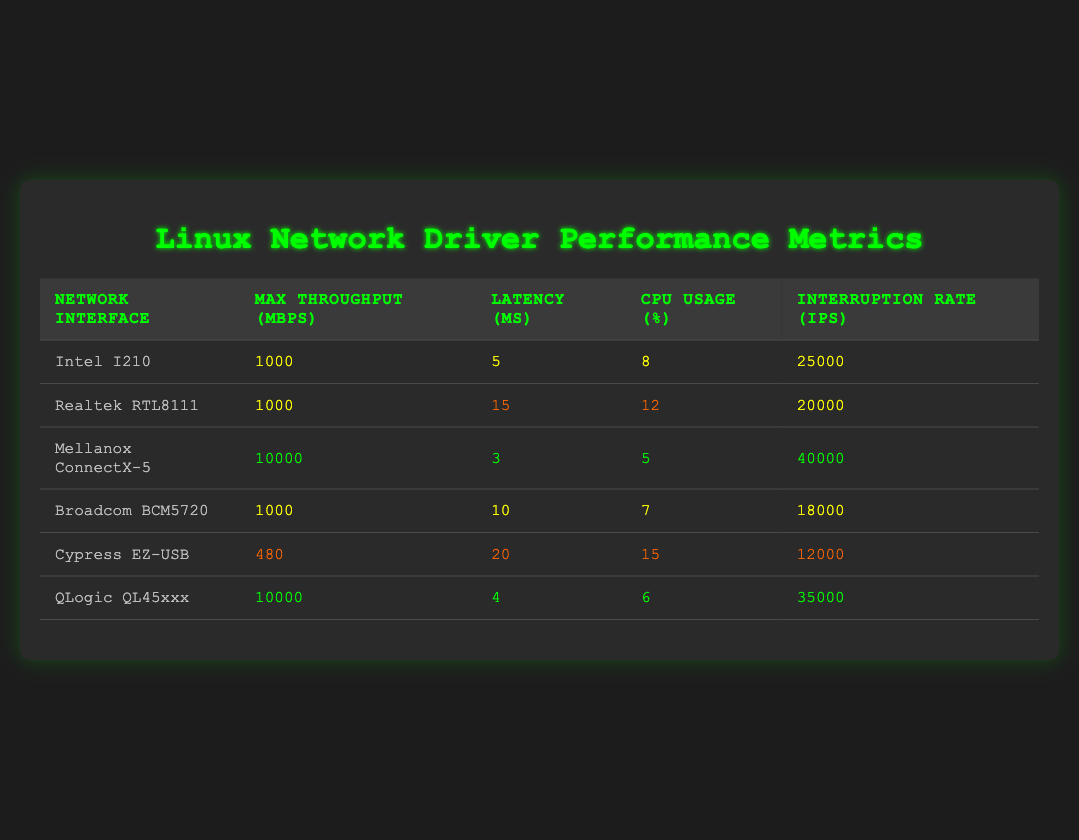What is the max throughput of the Realtek RTL8111? The max throughput for the Realtek RTL8111, as shown in the table, is specifically listed under the "Max Throughput (Mbps)" column, where it states 1000 Mbps.
Answer: 1000 Mbps Which network interface has the lowest CPU usage? By comparing the CPU usage percentage across all the entries in the table, the Cypress EZ-USB has the lowest CPU usage at 15%.
Answer: Cypress EZ-USB What is the average latency of network interfaces with a max throughput of 1000 Mbps? The relevant entries with a max throughput of 1000 Mbps are Intel I210, Realtek RTL8111, Broadcom BCM5720. Their latencies are 5, 15, and 10 microseconds respectively. Adding these gives 5 + 15 + 10 = 30 microseconds, and there are 3 entries, so the average is 30/3 = 10 microseconds.
Answer: 10 microseconds Is the interruption rate of Mellanox ConnectX-5 higher than that of Broadcom BCM5720? By examining the "Interruption Rate (IPS)" column, Mellanox ConnectX-5 has an interruption rate of 40000 IPS, while Broadcom BCM5720 has 18000 IPS. Since 40000 is greater than 18000, the statement is true.
Answer: Yes Which network interface has the highest max throughput and the lowest latency? From the table, the Mellanox ConnectX-5 has the highest max throughput at 10000 Mbps with the lowest latency of 3 microseconds. This indicates it outperforms other interfaces across these two metrics.
Answer: Mellanox ConnectX-5 What is the difference in CPU usage between the highest and lowest CPU usage metrics? The highest CPU usage is from Cypress EZ-USB at 15%, while the lowest is from Mellanox ConnectX-5 at 5%. The difference is calculated as 15 - 5 = 10 percent.
Answer: 10 percent Does the QLogic QL45xxx have a lower latency than the Intel I210? Checking the latencies, QLogic QL45xxx has 4 microseconds and Intel I210 has 5 microseconds. Since 4 microseconds is less than 5 microseconds, the statement is true.
Answer: Yes 